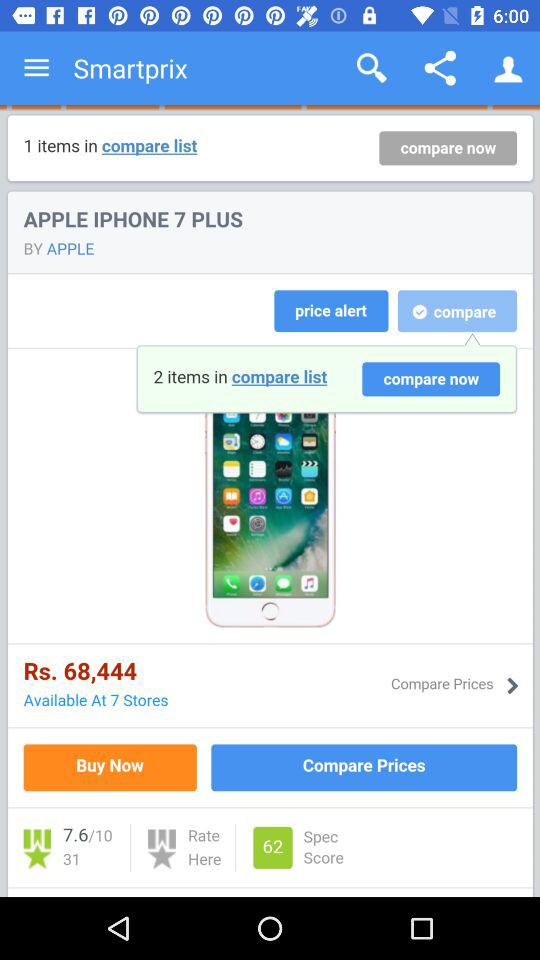What is the application name? The application name is "Smartprix". 